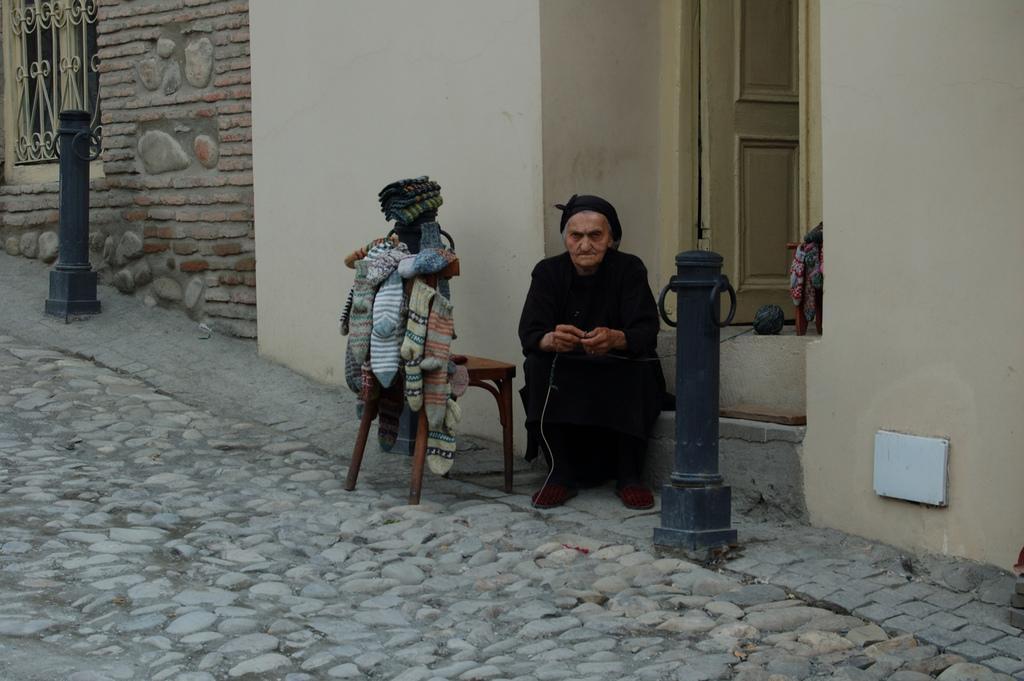Describe this image in one or two sentences. This picture is clicked outside the city. The woman in the black dress is sitting on the staircase in front of the door. Beside her, we see a pillar and we even see a chair on which many socks are hanged. Behind her, we see a wall which is in white color and beside that, we see a wall which is made up of red colored bricks and we even see a window. 